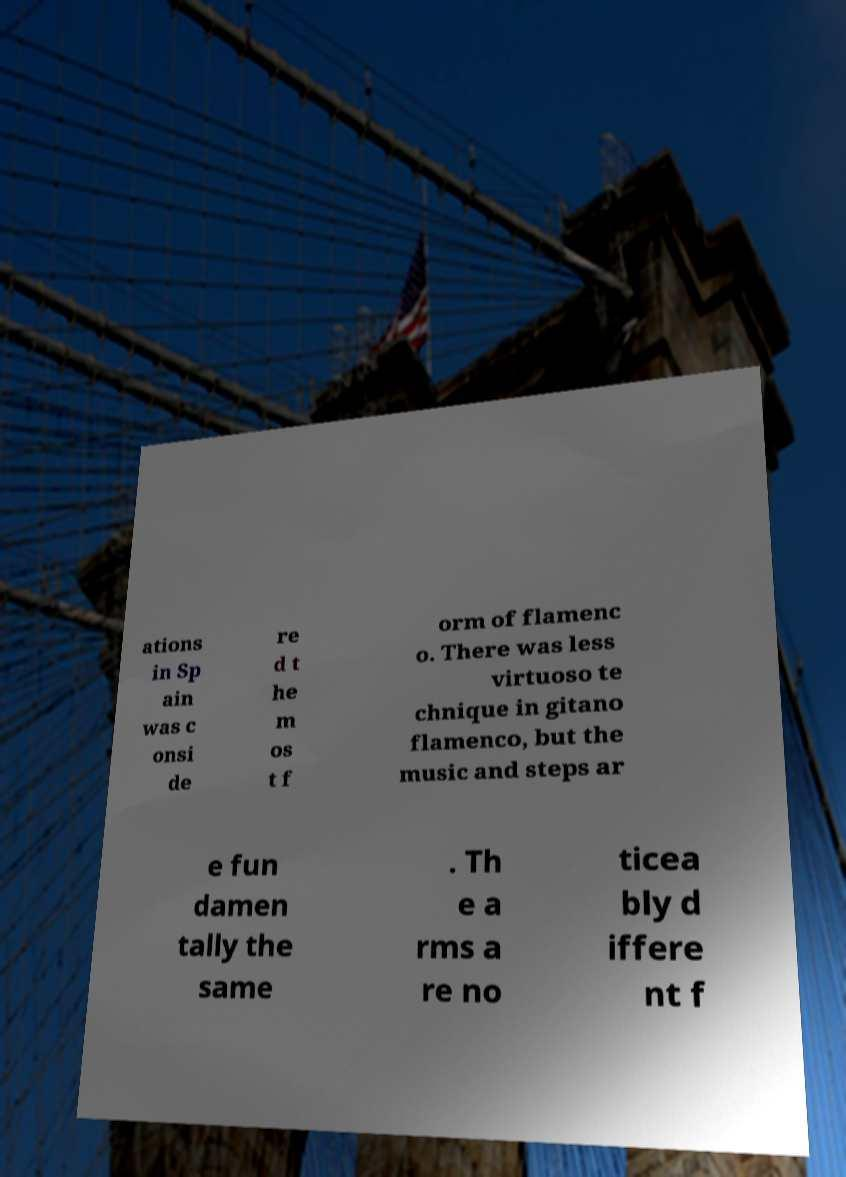What messages or text are displayed in this image? I need them in a readable, typed format. ations in Sp ain was c onsi de re d t he m os t f orm of flamenc o. There was less virtuoso te chnique in gitano flamenco, but the music and steps ar e fun damen tally the same . Th e a rms a re no ticea bly d iffere nt f 